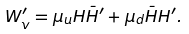<formula> <loc_0><loc_0><loc_500><loc_500>W ^ { \prime } _ { v } = \mu _ { u } H { \bar { H } } ^ { \prime } + \mu _ { d } { \bar { H } } H ^ { \prime } .</formula> 